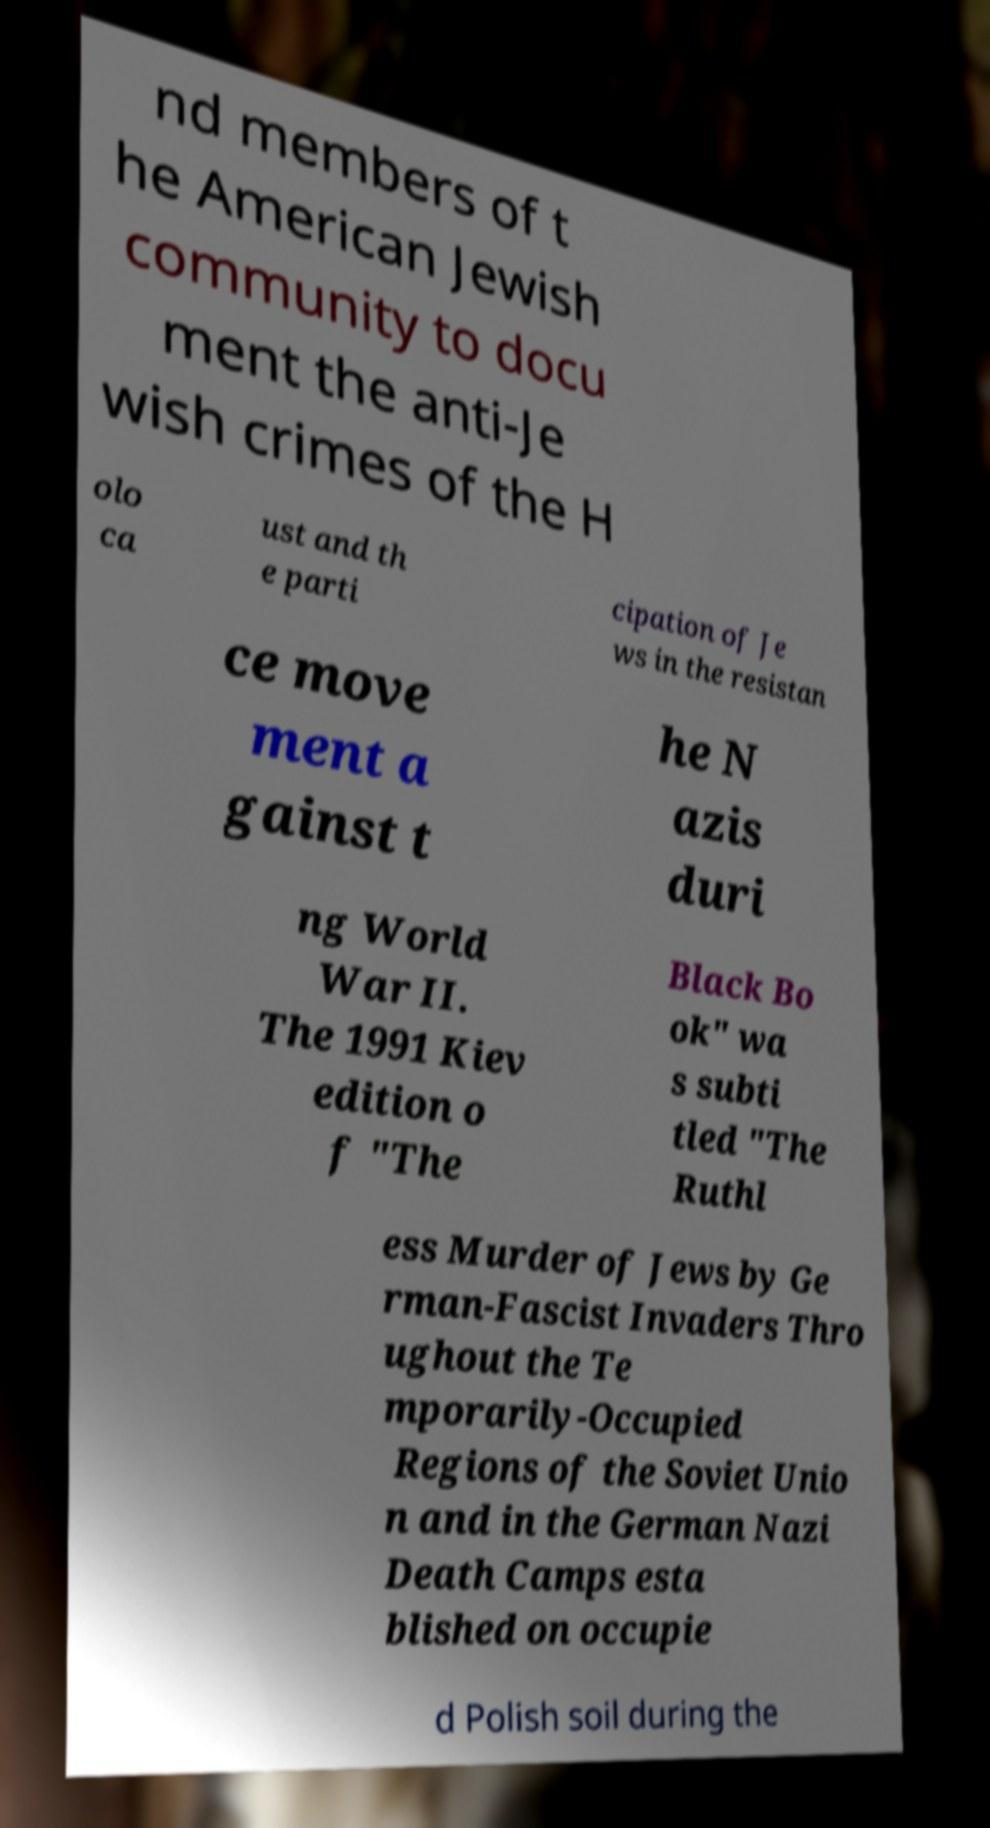Can you read and provide the text displayed in the image?This photo seems to have some interesting text. Can you extract and type it out for me? nd members of t he American Jewish community to docu ment the anti-Je wish crimes of the H olo ca ust and th e parti cipation of Je ws in the resistan ce move ment a gainst t he N azis duri ng World War II. The 1991 Kiev edition o f "The Black Bo ok" wa s subti tled "The Ruthl ess Murder of Jews by Ge rman-Fascist Invaders Thro ughout the Te mporarily-Occupied Regions of the Soviet Unio n and in the German Nazi Death Camps esta blished on occupie d Polish soil during the 